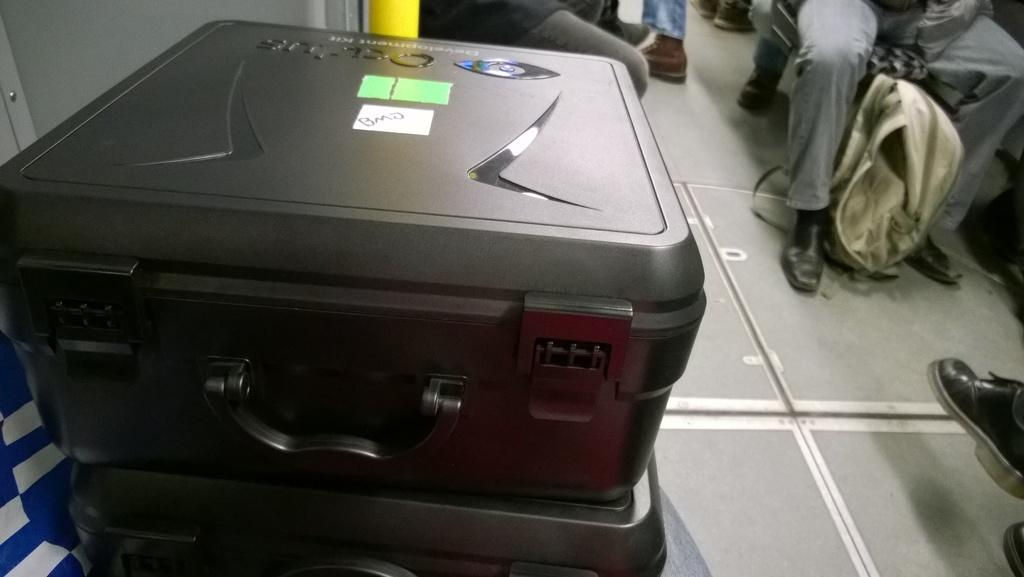What objects are in the foreground of the image? There are suitcases in the foreground of the image. What can be seen in the background of the image? There are people sitting in the background of the image. What type of plant is being used as a parent in the image? There is no plant or reference to parenting in the image; it features suitcases in the foreground and people sitting in the background. What color is the yarn being used by the people in the image? There is no yarn present in the image. 